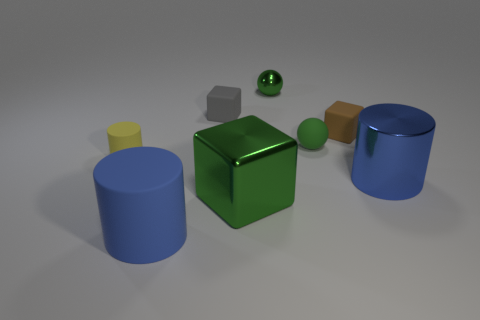There is a small sphere behind the brown matte thing; what material is it?
Provide a short and direct response. Metal. Are there an equal number of large green metallic things that are right of the green metallic cube and brown metal balls?
Your response must be concise. Yes. Is there any other thing that has the same size as the metal cylinder?
Your response must be concise. Yes. What material is the thing in front of the block in front of the yellow thing?
Your response must be concise. Rubber. There is a shiny object that is left of the large blue metal cylinder and in front of the tiny shiny sphere; what shape is it?
Give a very brief answer. Cube. What size is the metal thing that is the same shape as the brown matte thing?
Your answer should be very brief. Large. Are there fewer yellow objects on the right side of the green matte object than blue shiny objects?
Your response must be concise. Yes. There is a green ball that is in front of the small brown object; what is its size?
Make the answer very short. Small. What color is the metal thing that is the same shape as the small yellow rubber object?
Offer a terse response. Blue. What number of blocks have the same color as the tiny rubber sphere?
Your answer should be compact. 1. 